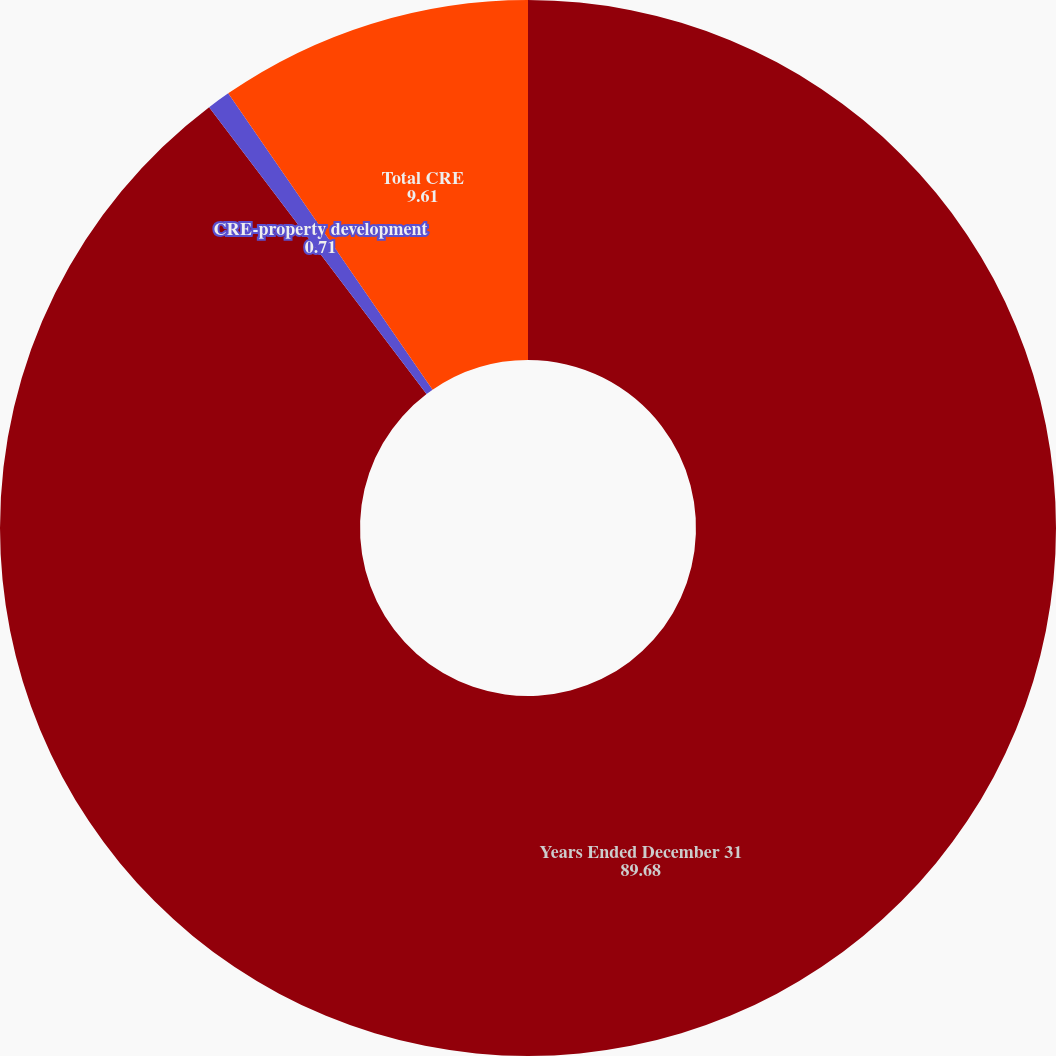Convert chart to OTSL. <chart><loc_0><loc_0><loc_500><loc_500><pie_chart><fcel>Years Ended December 31<fcel>CRE-property development<fcel>Total CRE<nl><fcel>89.68%<fcel>0.71%<fcel>9.61%<nl></chart> 